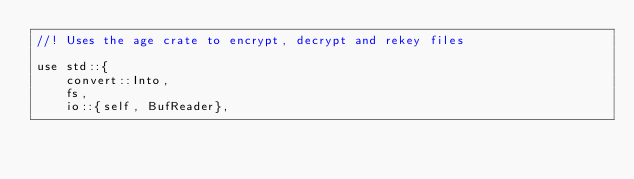<code> <loc_0><loc_0><loc_500><loc_500><_Rust_>//! Uses the age crate to encrypt, decrypt and rekey files

use std::{
    convert::Into,
    fs,
    io::{self, BufReader},</code> 